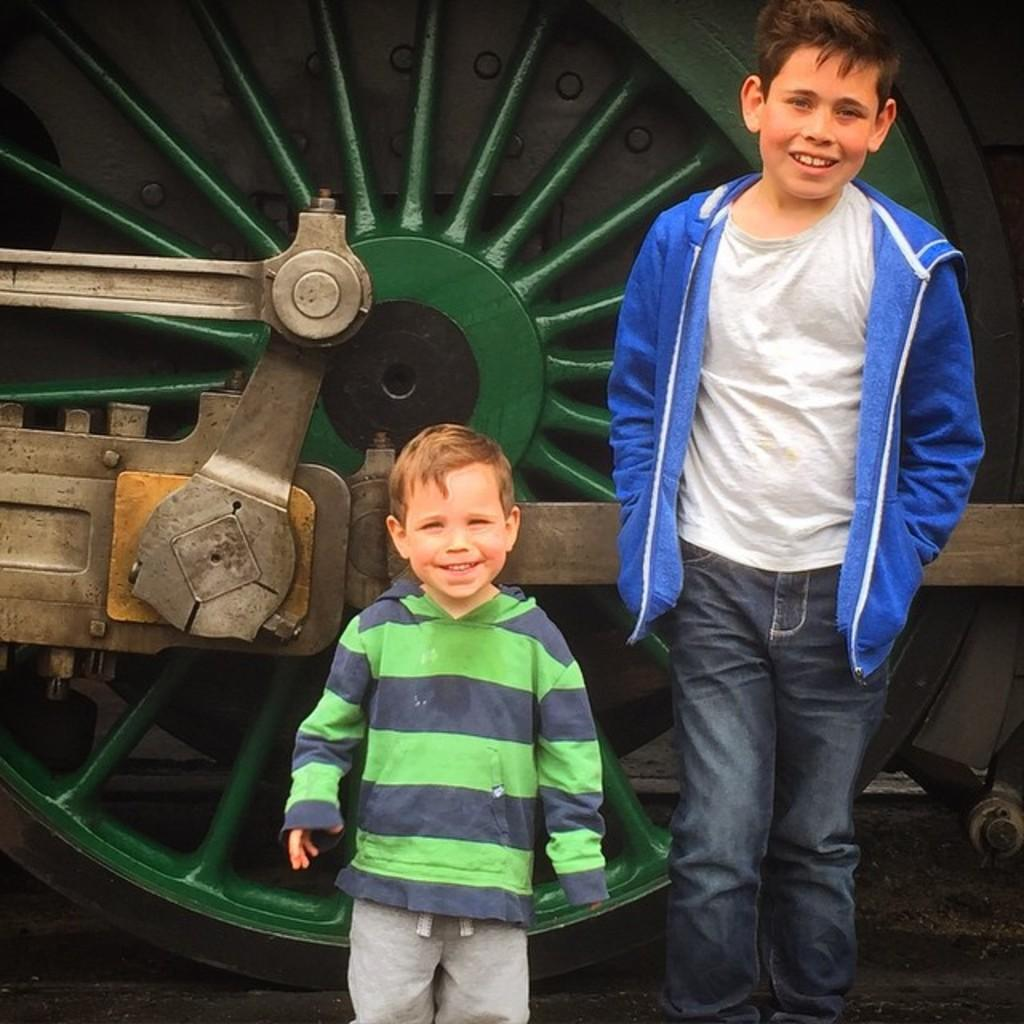What is the gender of the child in the image? There is a boy in the image. What is the child doing in the image? Both the child and the boy are standing and smiling. What can be seen in the background of the image? There is a green color wheel in the background of the image. What type of bait is the child using to catch fish in the image? There is no indication of fishing or bait in the image; the child is simply standing and smiling. What liquid is present in the image? There is no liquid visible in the image; it primarily features the child, the boy, and the green color wheel in the background. 